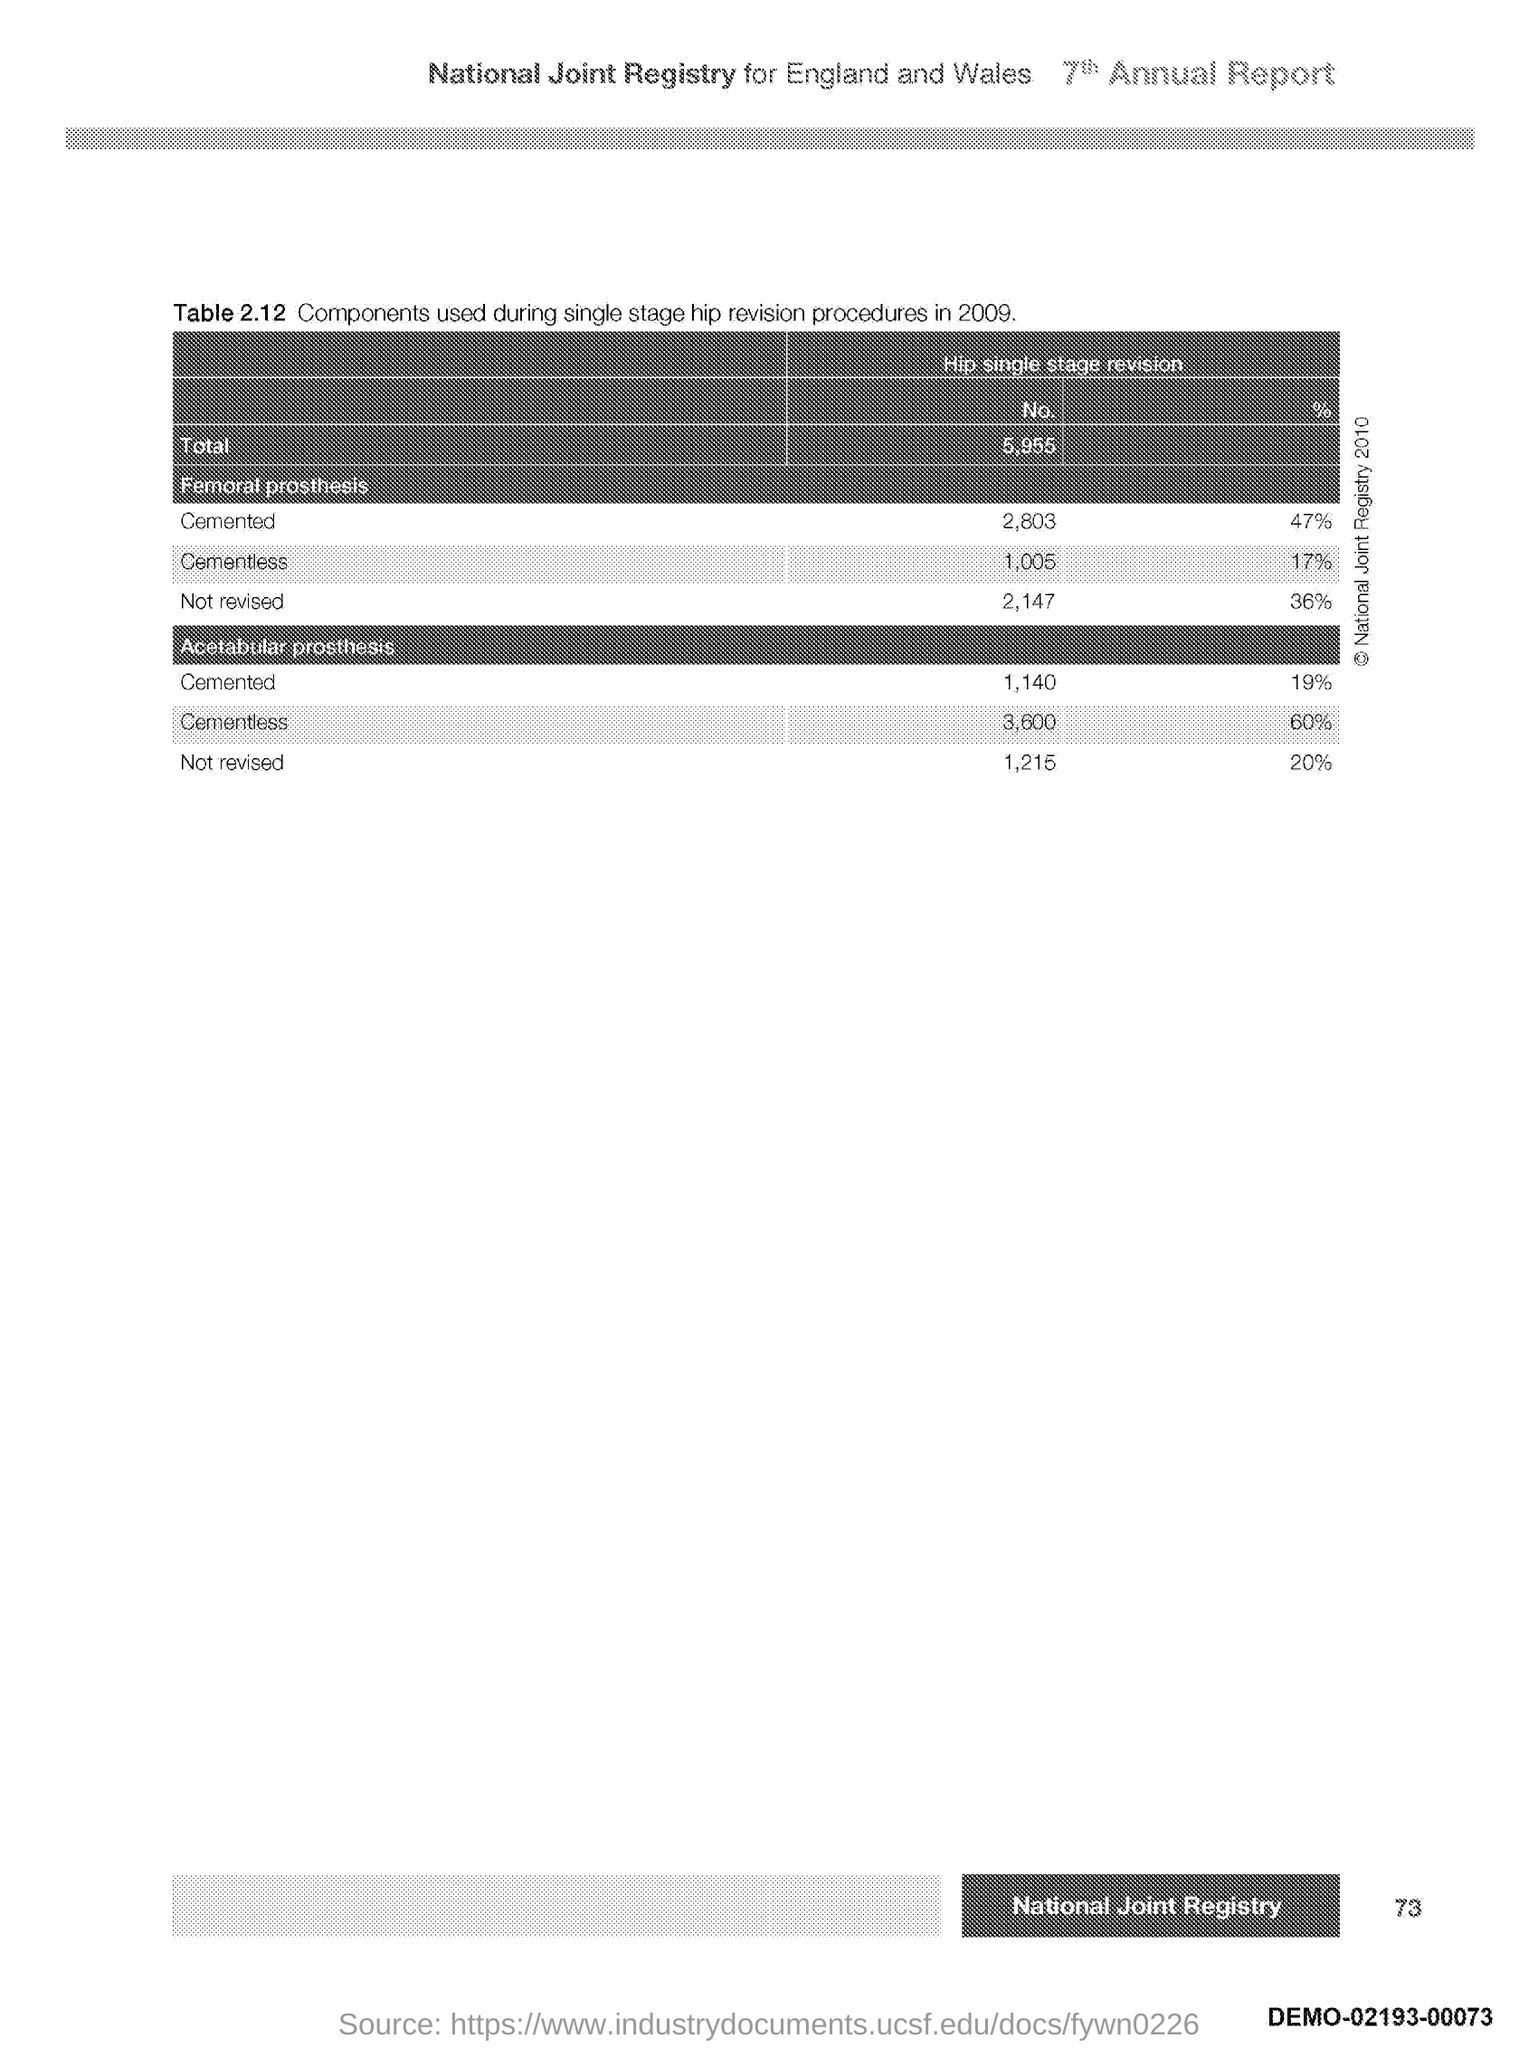Point out several critical features in this image. Page 73 contains the information you requested. 